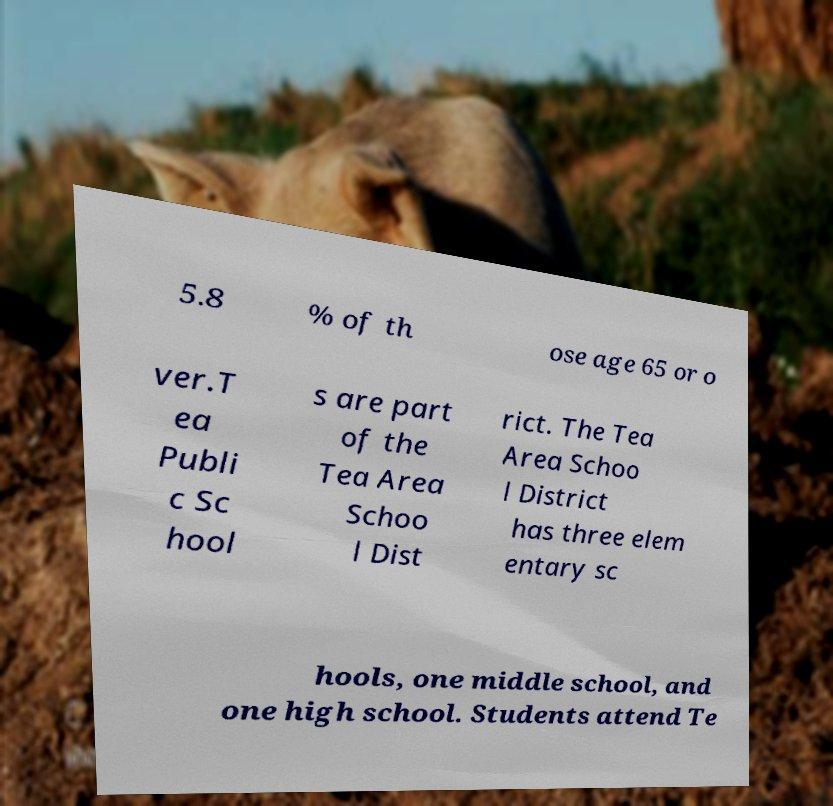I need the written content from this picture converted into text. Can you do that? 5.8 % of th ose age 65 or o ver.T ea Publi c Sc hool s are part of the Tea Area Schoo l Dist rict. The Tea Area Schoo l District has three elem entary sc hools, one middle school, and one high school. Students attend Te 